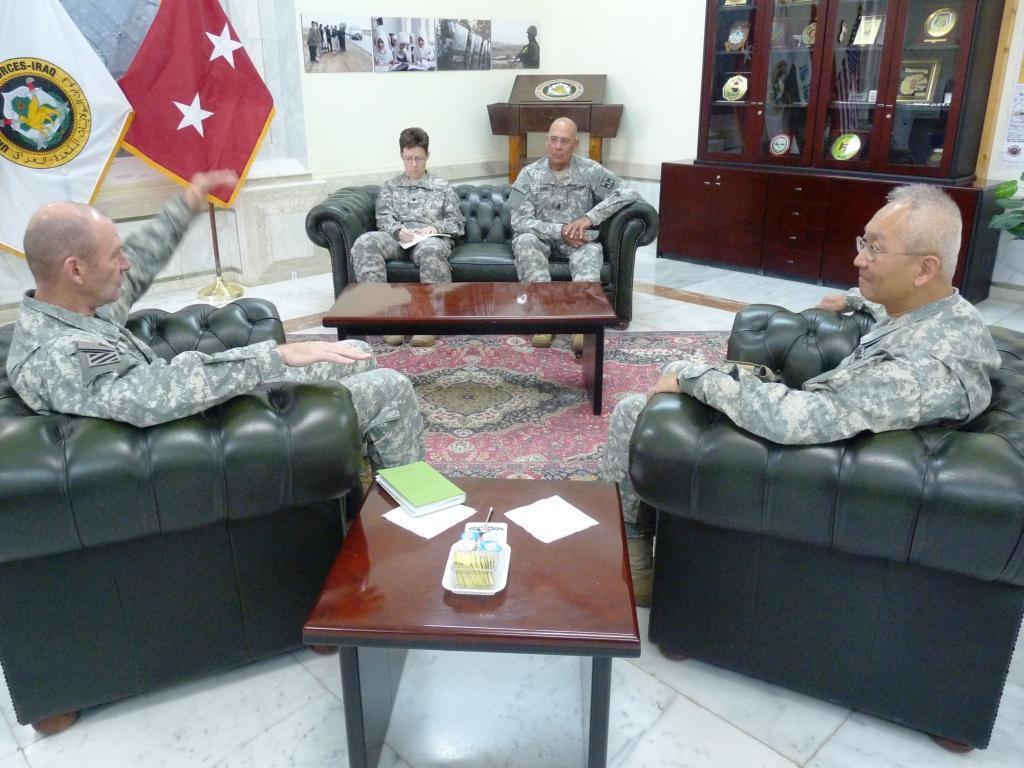How would you summarize this image in a sentence or two? In this picture there are four men sitting on the chair. There is a book, paper, pencil ,tray on the table. There are flags. There is a poster on the wall. There are shields in the shelf. There is plant and a carpet. 